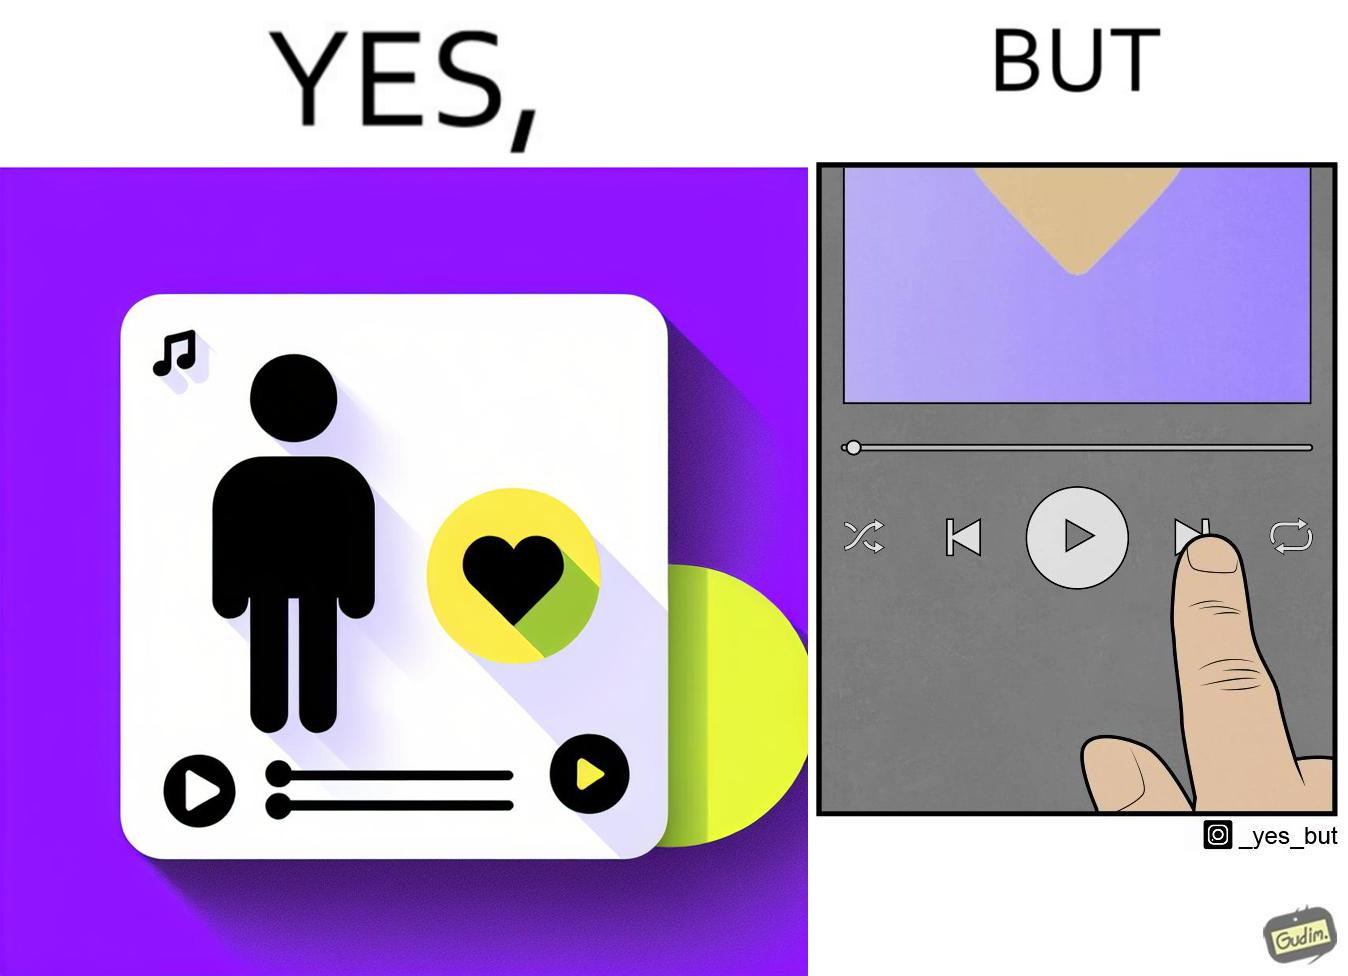Why is this image considered satirical? The image is funny because while the playlist is labelled "music I love" indicating that all the music in the playlist is very well liked by the user but the user is pressing play next button after listening to a few seconds of one of the audios in the playlist. 